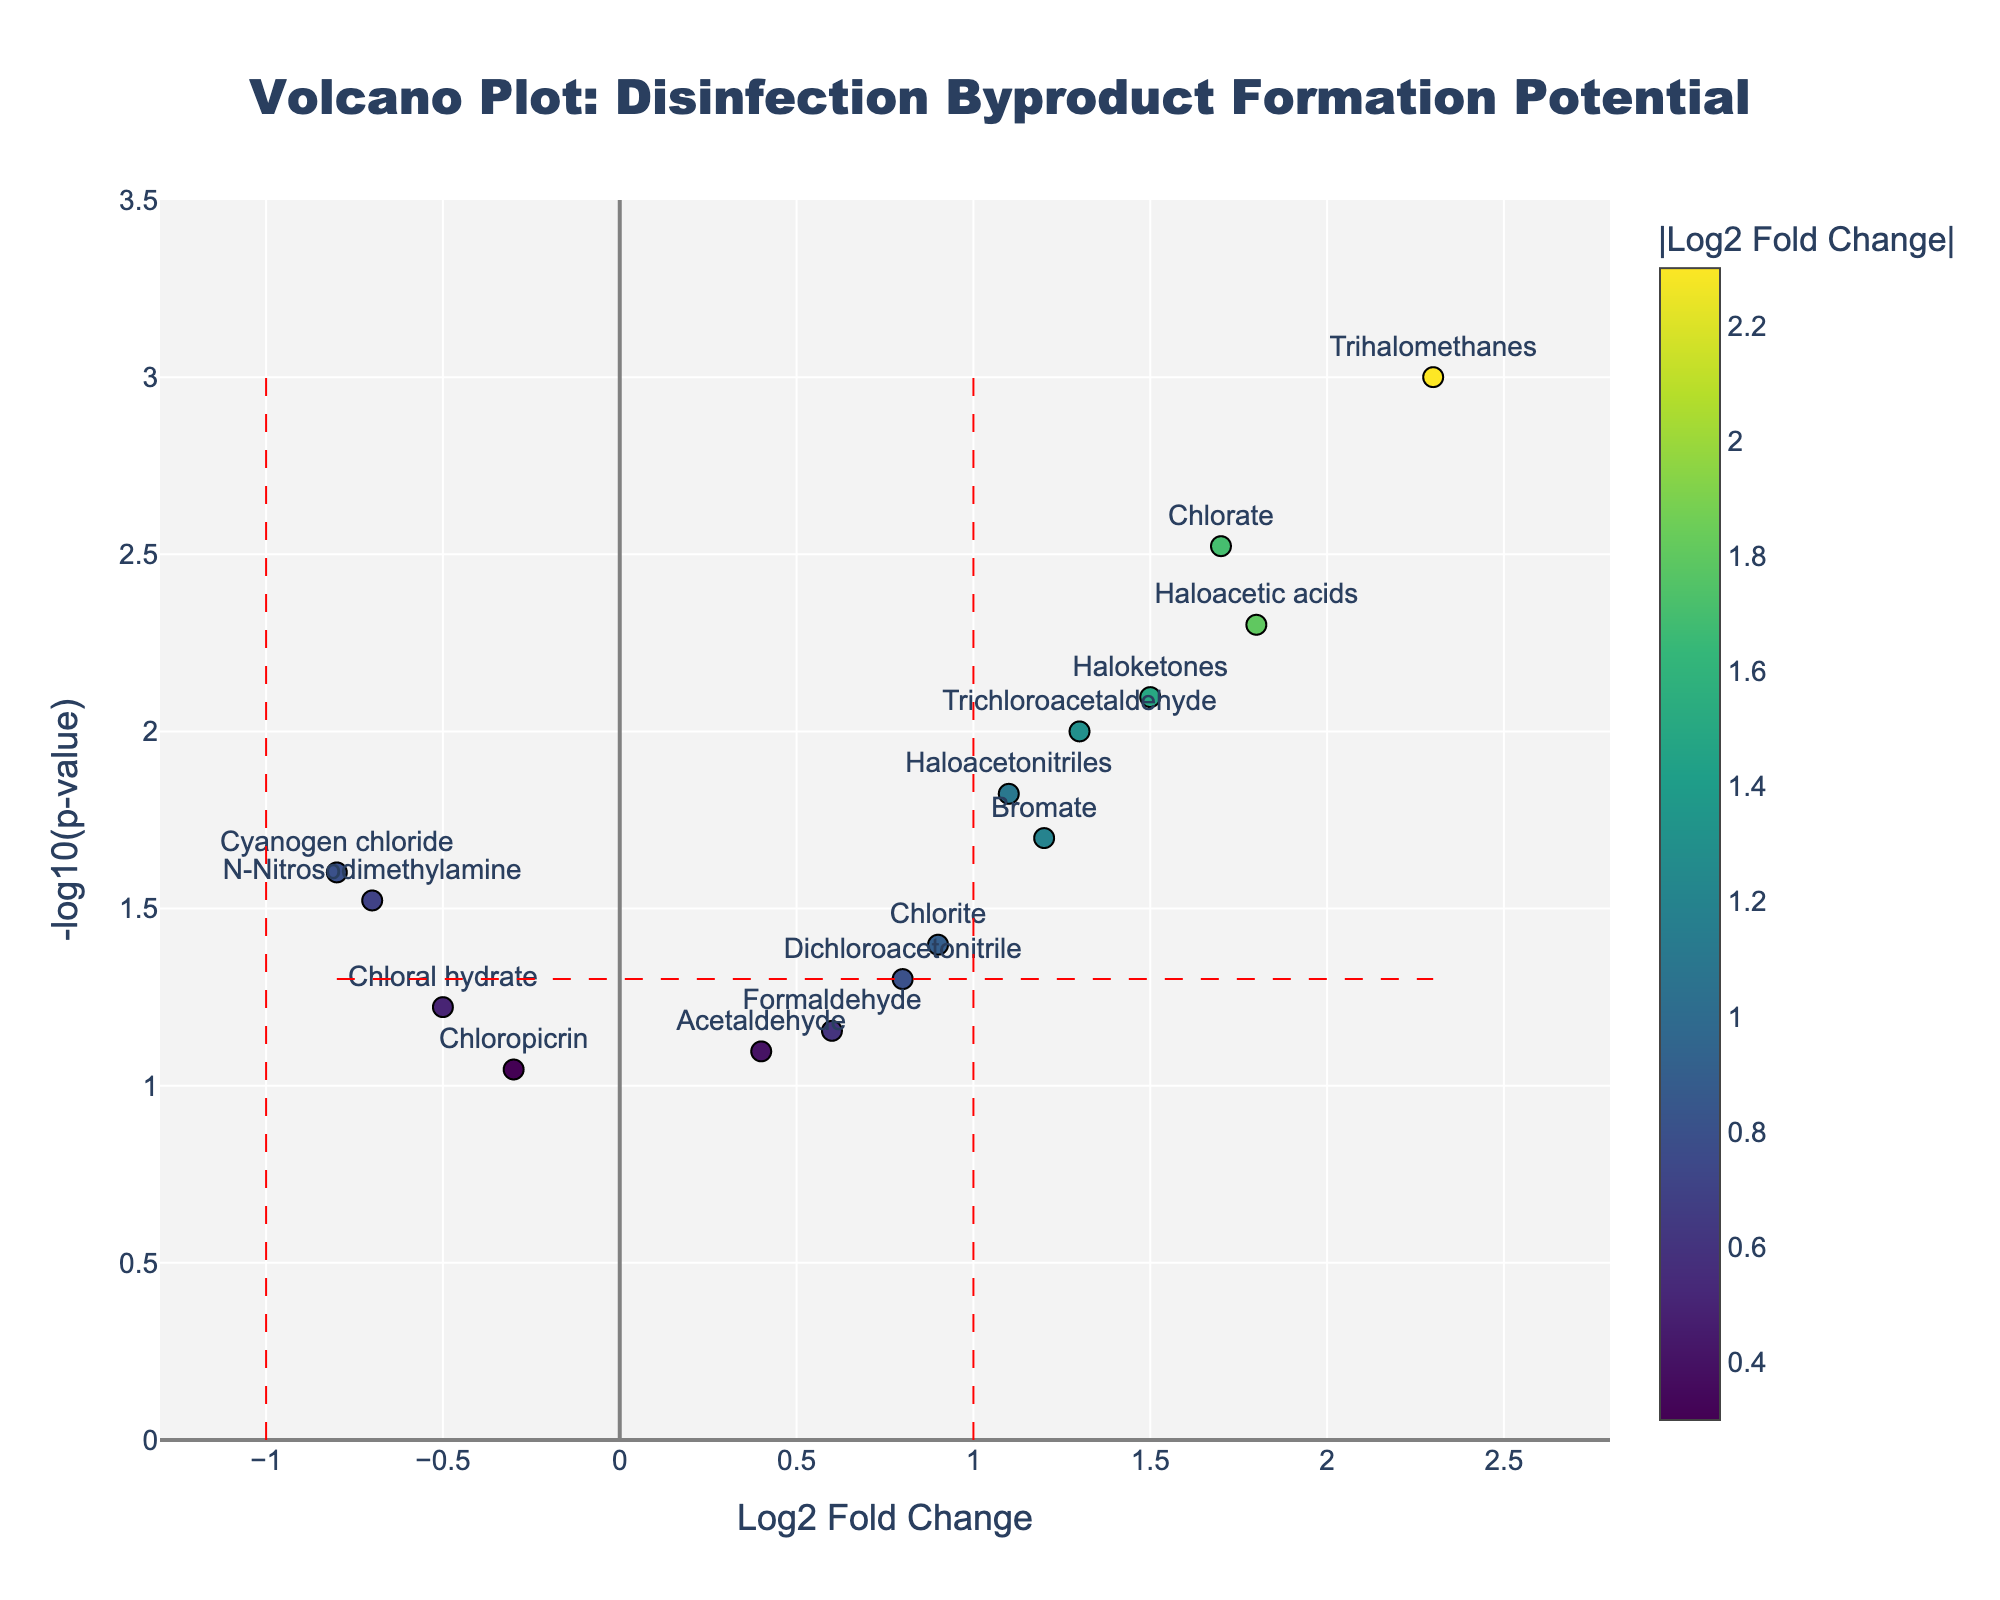Which compound has the highest -log10(p-value)? To determine this, look at the y-axis, which shows the -log10(p-value). The compound with the highest value on the y-axis is Trihalomethanes.
Answer: Trihalomethanes What is the log2 fold change for Chloral hydrate? Locate Chloral hydrate on the plot, then look at its position on the x-axis to determine its log2 fold change. Chloral hydrate is located around -0.5 on the x-axis.
Answer: -0.5 How many compounds have a p-value less than 0.05? Compounds with p-value less than 0.05 will have -log10(p-value) values higher than 1.3 (since -log10(0.05) ≈ 1.3). Count the points above this threshold. There are eight such compounds.
Answer: 8 Which compound has the smallest absolute log2 fold change? To find this, look for the compound closest to zero on the x-axis. The compounds closest to zero are Chloral hydrate and Chloropicrin.
Answer: Chloral hydrate and Chloropicrin Compare the log2 fold changes of Trichloroacetaldehyde and Cyanogen chloride. Which one is higher? Locate both compounds on the plot and compare their positions on the x-axis. Trichloroacetaldehyde is around 1.3, and Cyanogen chloride is around -0.8.
Answer: Trichloroacetaldehyde Which compound is just above the p-value significance threshold and has the highest log2 fold change? First, look for compounds with a -log10(p-value) just above the threshold (around 1.3) and then find the one with the highest log2 fold change. Chlorate stands out with a log2 fold change of 1.7 just above the threshold.
Answer: Chlorate What is the log2 fold change range for the plotted compounds? Identify the minimum and maximum values on the x-axis where data points are present. The range is from approximately -0.8 (Cyanogen chloride) to 2.3 (Trihalomethanes).
Answer: -0.8 to 2.3 Are there any compounds with negative log2 fold changes that have significant p-values? For a compound with a significant p-value, it must be above the -log10(p-value) threshold line (1.3). There is one compound, N-Nitrosodimethylamine, with a negative log2 fold change and -log10(p-value) above 1.3.
Answer: N-Nitrosodimethylamine 